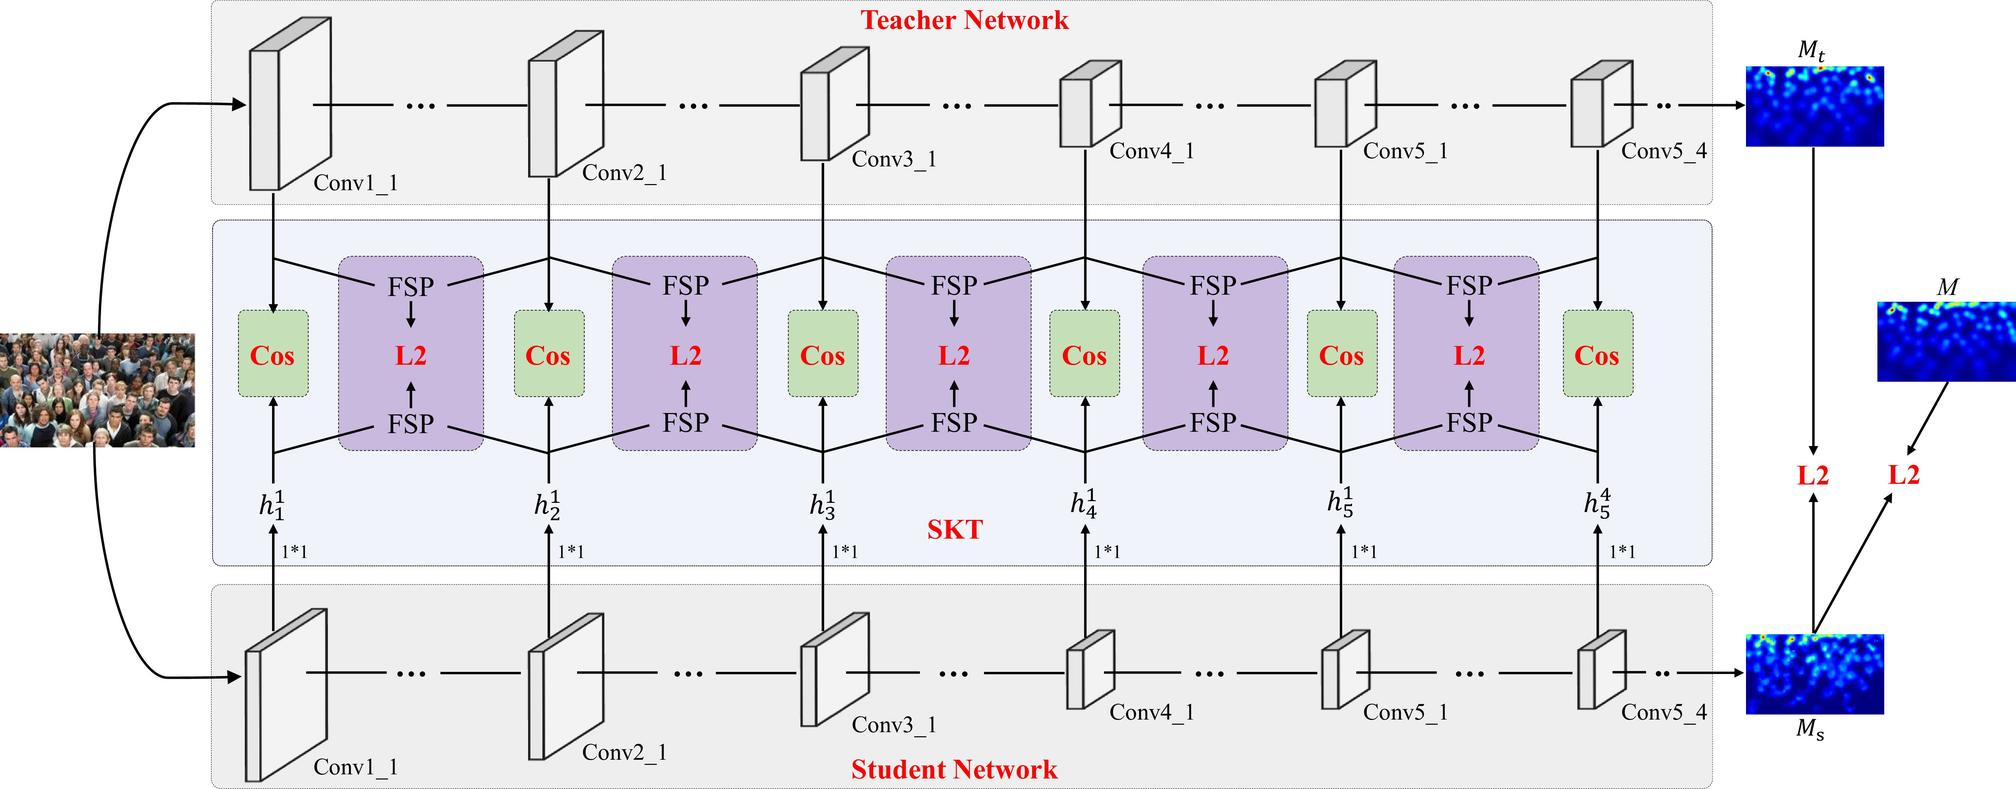Can you explain what knowledge distillation is in the context of this diagram? Knowledge distillation is a machine learning technique depicted in this diagram where a smaller, simpler 'student' network is trained to mimic the behavior of a larger, more complex 'teacher' network. The goal is to transfer the knowledge from the teacher to the student network so that the student can achieve comparable performance with less computational cost. The process typically involves comparing the outputs and feature representations between the teacher and student networks to guide the student's learning and encourage it to adopt similar internal representations. Methods like Feature Similarity Profile (FSP) comparison, represented in the diagram by 'FSP' blocks, and cosine distance metrics, indicated by 'Cos', are used to ensure that the student's features match closely with those of the teacher's, thereby effectively distilling the knowledge. 